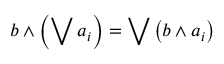<formula> <loc_0><loc_0><loc_500><loc_500>b \wedge \left ( \bigvee a _ { i } \right ) = \bigvee \left ( b \wedge a _ { i } \right )</formula> 